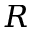Convert formula to latex. <formula><loc_0><loc_0><loc_500><loc_500>R</formula> 